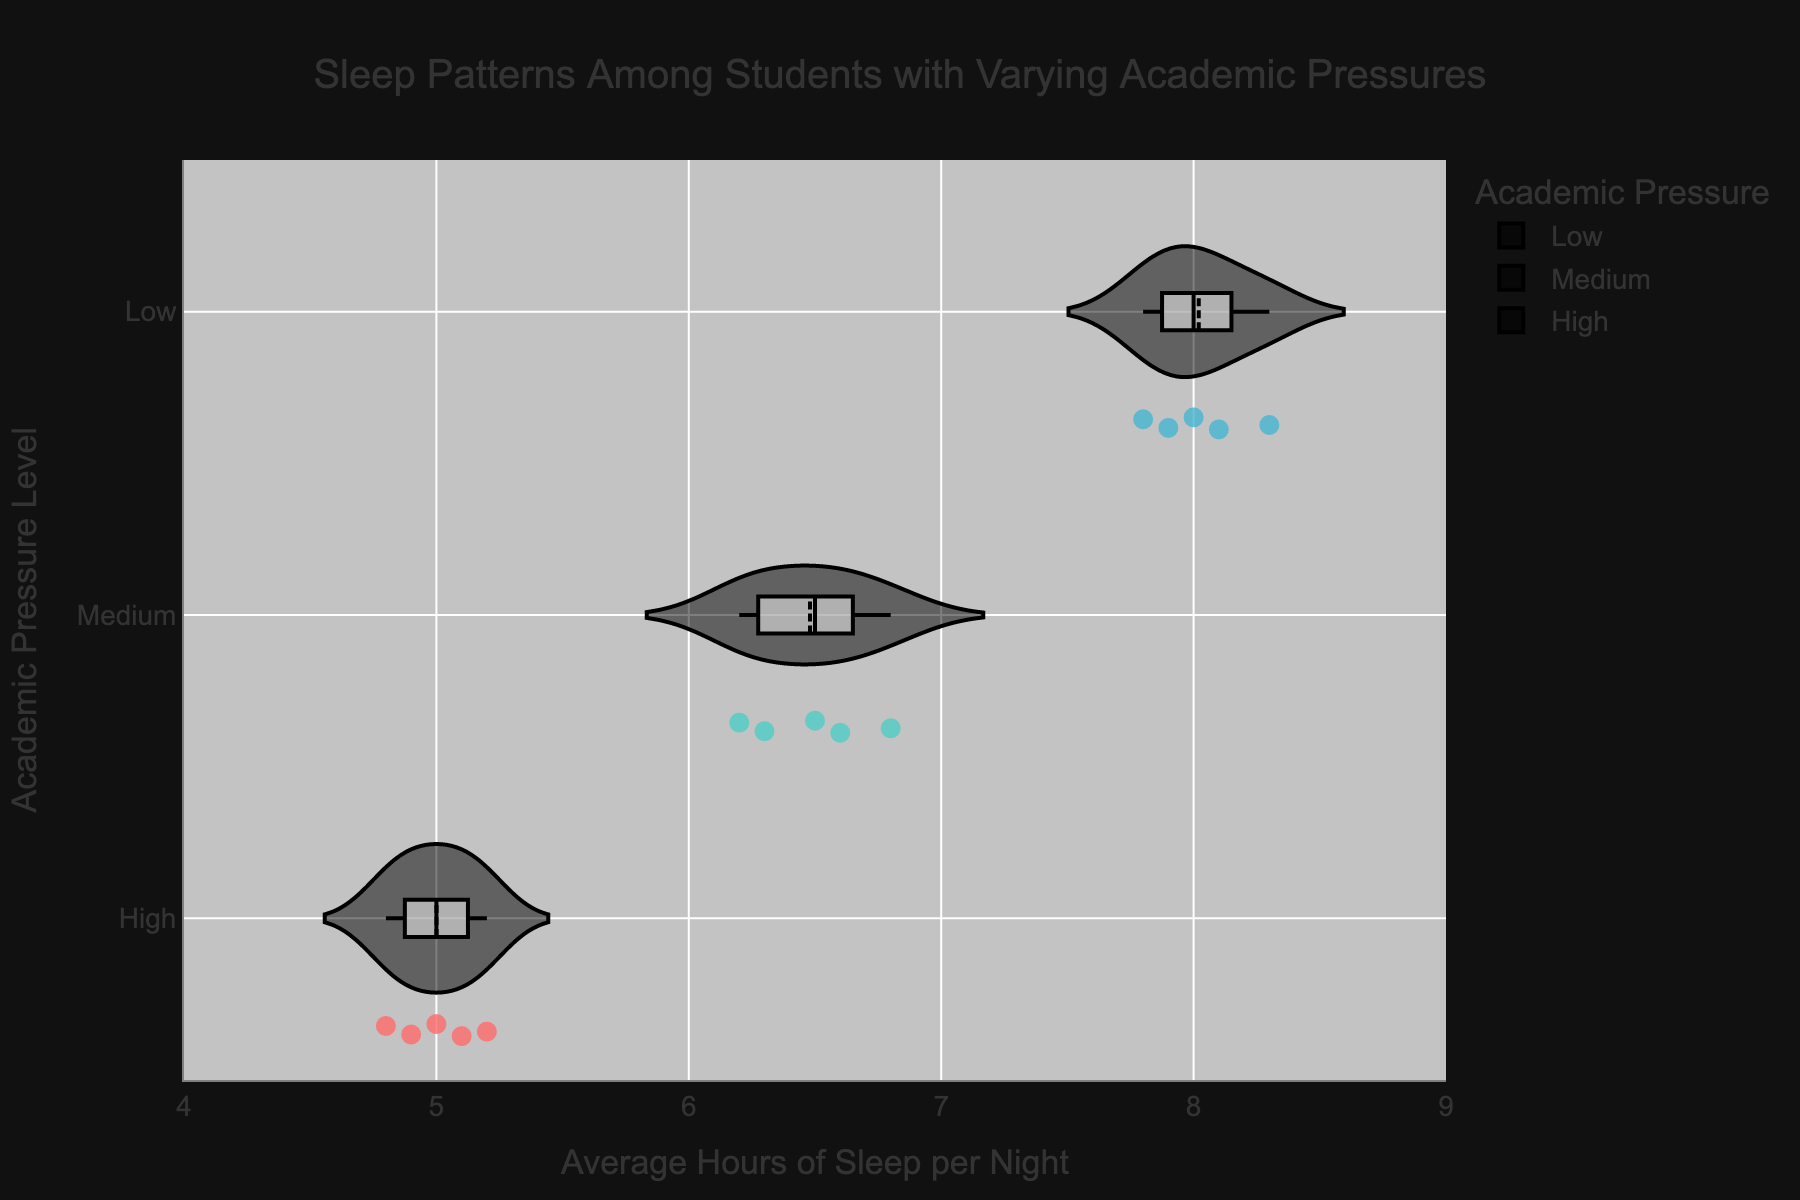How many students are represented in the figure? To find the number of students, count the number of data points within the figure. Each violin plot shows individual points for each student's sleep hours.
Answer: 15 What is the range of average hours of sleep per night for students with high academic pressure? The range can be identified by looking at the minimum and maximum points for the "High" academic pressure violin plot. The points range from 4.8 to 5.2 hours.
Answer: 4.8 to 5.2 hours Which academic pressure group shows the highest median value of sleep hours? The median values are visible as horizontal lines within the box plot of each violin. By comparing these lines, the "Low" academic pressure group has the highest median.
Answer: Low How does the average sleep duration of the "Medium" academic pressure group compare with the "High" group? Compare the center distribution (mean or median) lines of the violin plots for both "Medium" and "High" academic pressure. The "Medium" group has a higher average sleep duration than the "High" group.
Answer: Medium group has higher sleep duration What is the typical sleep range for students with low academic pressure based on the violin plot? Examine the spread of data points within the "Low" academic pressure violin plot. The data ranges approximately from 7.8 to 8.3 hours.
Answer: 7.8 to 8.3 hours Are there any outliers in the data for each academic pressure group? Outliers would appear as individual points far from the central mass of the violin plot. No significant outliers are visible for any of the academic pressure groups.
Answer: No outliers visible Which group has the most consistent sleep duration among its students? Consistency can be assessed by the narrowness of the violin plots. The "High" academic pressure group has the narrowest plot, indicating the most consistent sleep duration.
Answer: High group 